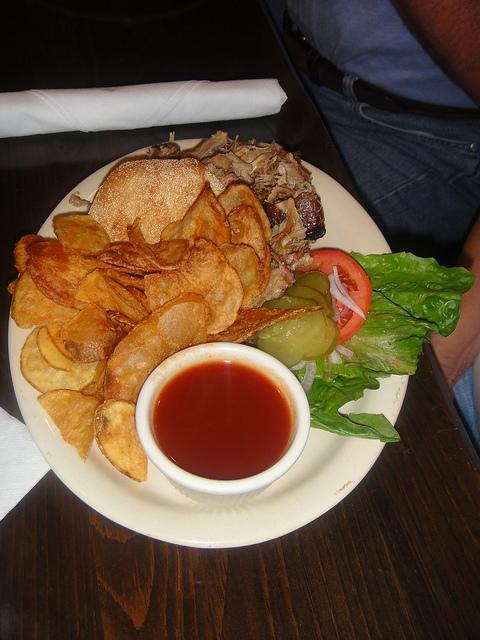Verify the accuracy of this image caption: "The person is touching the sandwich.".
Answer yes or no. No. 